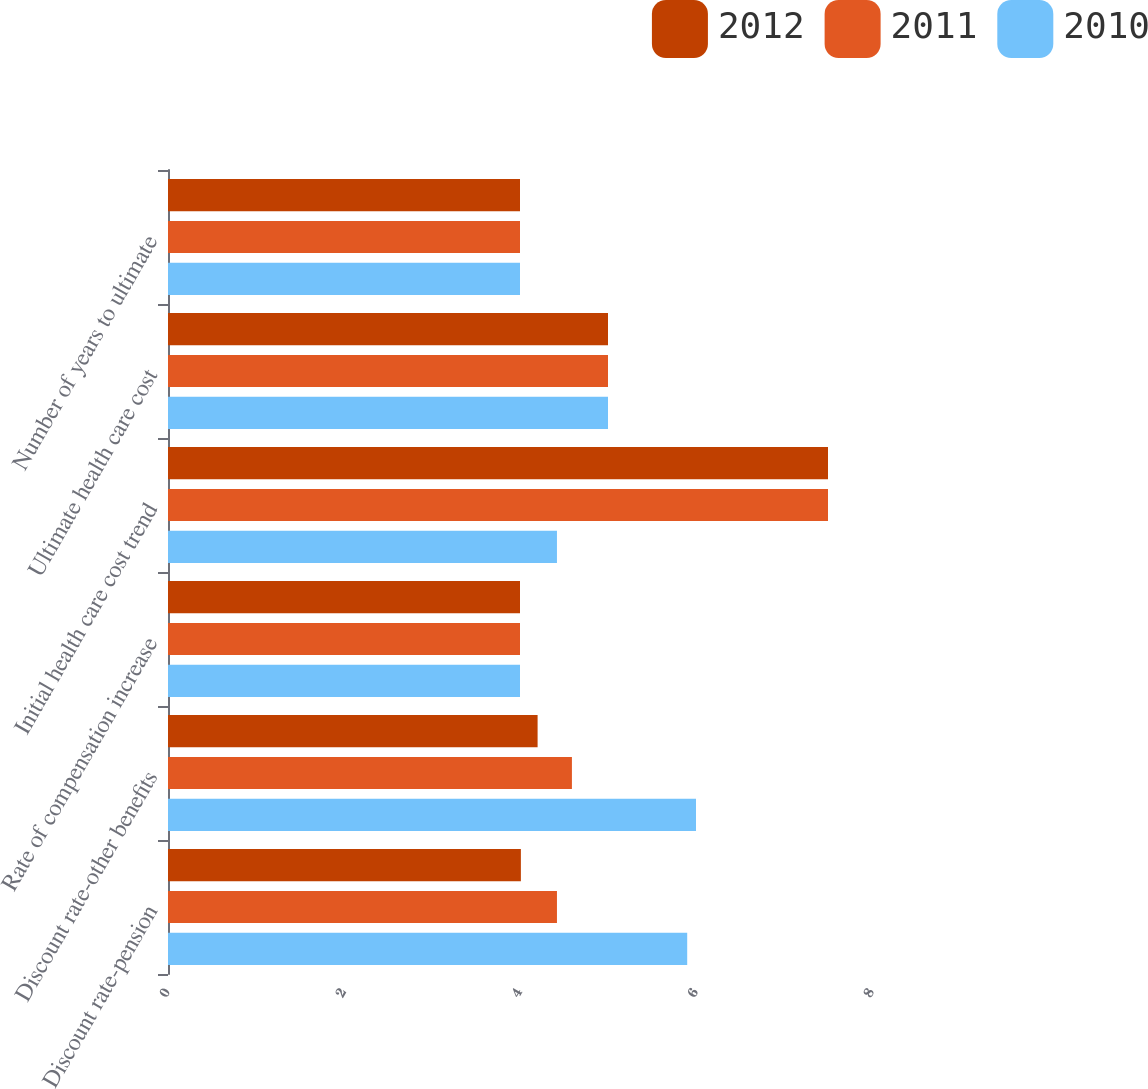Convert chart to OTSL. <chart><loc_0><loc_0><loc_500><loc_500><stacked_bar_chart><ecel><fcel>Discount rate-pension<fcel>Discount rate-other benefits<fcel>Rate of compensation increase<fcel>Initial health care cost trend<fcel>Ultimate health care cost<fcel>Number of years to ultimate<nl><fcel>2012<fcel>4.01<fcel>4.2<fcel>4<fcel>7.5<fcel>5<fcel>4<nl><fcel>2011<fcel>4.42<fcel>4.59<fcel>4<fcel>7.5<fcel>5<fcel>4<nl><fcel>2010<fcel>5.9<fcel>6<fcel>4<fcel>4.42<fcel>5<fcel>4<nl></chart> 